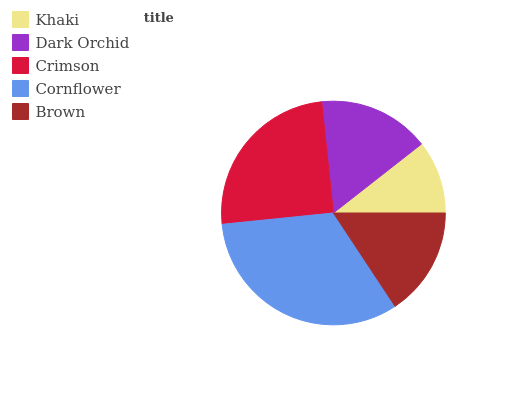Is Khaki the minimum?
Answer yes or no. Yes. Is Cornflower the maximum?
Answer yes or no. Yes. Is Dark Orchid the minimum?
Answer yes or no. No. Is Dark Orchid the maximum?
Answer yes or no. No. Is Dark Orchid greater than Khaki?
Answer yes or no. Yes. Is Khaki less than Dark Orchid?
Answer yes or no. Yes. Is Khaki greater than Dark Orchid?
Answer yes or no. No. Is Dark Orchid less than Khaki?
Answer yes or no. No. Is Dark Orchid the high median?
Answer yes or no. Yes. Is Dark Orchid the low median?
Answer yes or no. Yes. Is Khaki the high median?
Answer yes or no. No. Is Khaki the low median?
Answer yes or no. No. 